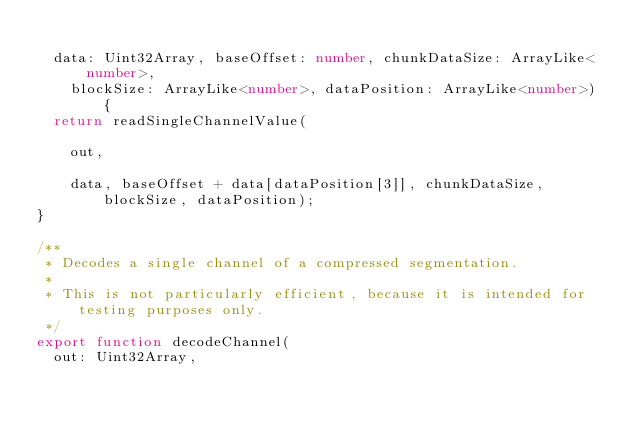Convert code to text. <code><loc_0><loc_0><loc_500><loc_500><_TypeScript_>  
  data: Uint32Array, baseOffset: number, chunkDataSize: ArrayLike<number>,
    blockSize: ArrayLike<number>, dataPosition: ArrayLike<number>) {
  return readSingleChannelValue(
    
    out,
    
    data, baseOffset + data[dataPosition[3]], chunkDataSize, blockSize, dataPosition);
}

/**
 * Decodes a single channel of a compressed segmentation.
 *
 * This is not particularly efficient, because it is intended for testing purposes only.
 */
export function decodeChannel(
  out: Uint32Array,</code> 